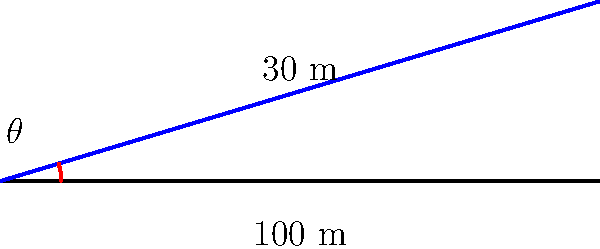In a smart water management system for a landscaped area, the ideal slope for efficient drainage is to be determined. The system needs to cover a horizontal distance of 100 meters with a vertical rise of 30 meters. What is the angle of inclination ($\theta$) for this slope? To find the angle of inclination ($\theta$), we can use the inverse tangent function (arctan or $\tan^{-1}$). Here's how we solve it step-by-step:

1. Identify the known variables:
   - Vertical rise (opposite side) = 30 meters
   - Horizontal distance (adjacent side) = 100 meters

2. Recall the tangent function in a right-angled triangle:
   $\tan(\theta) = \frac{\text{opposite}}{\text{adjacent}}$

3. Substitute the known values:
   $\tan(\theta) = \frac{30}{100} = 0.3$

4. To find $\theta$, we need to apply the inverse tangent function to both sides:
   $\theta = \tan^{-1}(0.3)$

5. Calculate the result:
   $\theta \approx 16.70^\circ$

Therefore, the angle of inclination for the ideal slope is approximately 16.70 degrees.
Answer: $16.70^\circ$ 